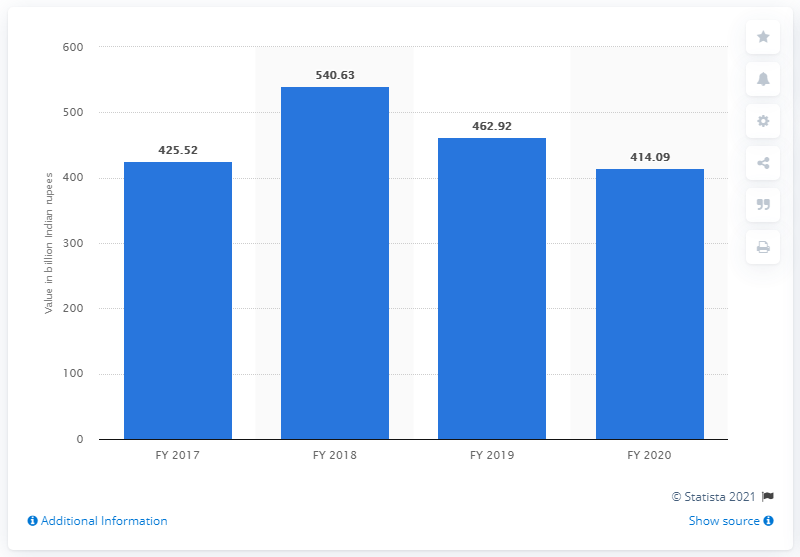Identify some key points in this picture. ICICI Bank Limited's gross non-performing assets in fiscal year 2020 were 414.09. The value of the gross NPAs (non-performing assets) filed by ICICI Bank Limited in the previous fiscal year was 462.92. 